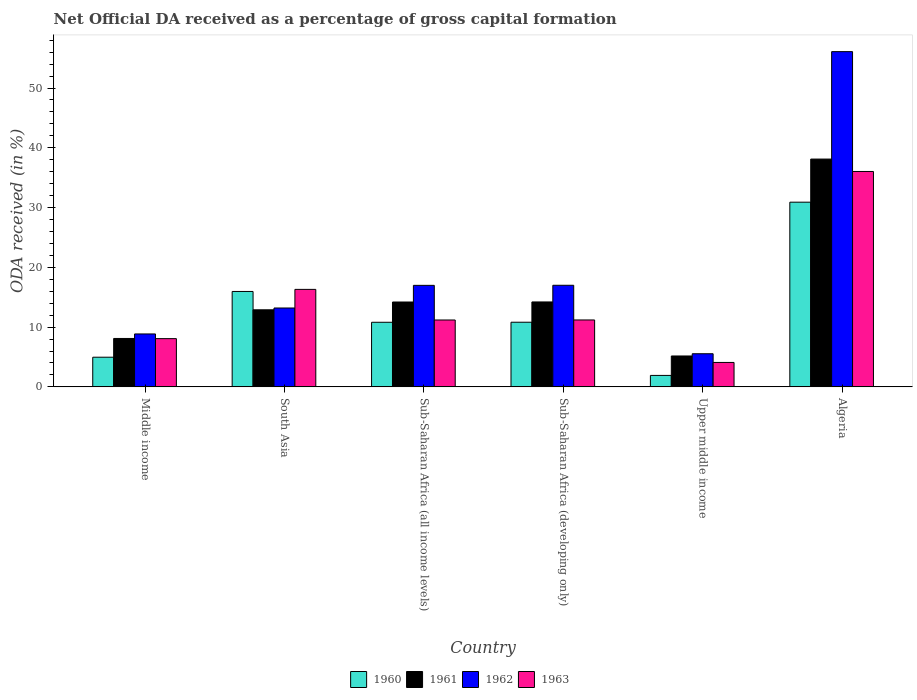Are the number of bars on each tick of the X-axis equal?
Keep it short and to the point. Yes. How many bars are there on the 1st tick from the right?
Give a very brief answer. 4. What is the label of the 2nd group of bars from the left?
Offer a very short reply. South Asia. What is the net ODA received in 1962 in Sub-Saharan Africa (all income levels)?
Offer a very short reply. 16.99. Across all countries, what is the maximum net ODA received in 1961?
Ensure brevity in your answer.  38.11. Across all countries, what is the minimum net ODA received in 1963?
Keep it short and to the point. 4.09. In which country was the net ODA received in 1961 maximum?
Your answer should be compact. Algeria. In which country was the net ODA received in 1961 minimum?
Provide a short and direct response. Upper middle income. What is the total net ODA received in 1960 in the graph?
Your response must be concise. 75.37. What is the difference between the net ODA received in 1963 in Sub-Saharan Africa (developing only) and that in Upper middle income?
Give a very brief answer. 7.11. What is the difference between the net ODA received in 1961 in Middle income and the net ODA received in 1963 in South Asia?
Keep it short and to the point. -8.21. What is the average net ODA received in 1960 per country?
Offer a terse response. 12.56. What is the difference between the net ODA received of/in 1963 and net ODA received of/in 1962 in Sub-Saharan Africa (all income levels)?
Keep it short and to the point. -5.8. What is the ratio of the net ODA received in 1963 in Algeria to that in South Asia?
Offer a terse response. 2.21. Is the net ODA received in 1961 in Algeria less than that in South Asia?
Offer a terse response. No. What is the difference between the highest and the second highest net ODA received in 1961?
Offer a very short reply. -23.91. What is the difference between the highest and the lowest net ODA received in 1962?
Your answer should be very brief. 50.54. In how many countries, is the net ODA received in 1963 greater than the average net ODA received in 1963 taken over all countries?
Offer a very short reply. 2. Is the sum of the net ODA received in 1960 in Sub-Saharan Africa (developing only) and Upper middle income greater than the maximum net ODA received in 1961 across all countries?
Your answer should be very brief. No. Is it the case that in every country, the sum of the net ODA received in 1961 and net ODA received in 1960 is greater than the sum of net ODA received in 1962 and net ODA received in 1963?
Make the answer very short. No. What does the 2nd bar from the right in Sub-Saharan Africa (developing only) represents?
Your answer should be compact. 1962. Are all the bars in the graph horizontal?
Keep it short and to the point. No. What is the difference between two consecutive major ticks on the Y-axis?
Offer a very short reply. 10. Does the graph contain grids?
Your answer should be very brief. No. Where does the legend appear in the graph?
Give a very brief answer. Bottom center. How many legend labels are there?
Offer a terse response. 4. What is the title of the graph?
Keep it short and to the point. Net Official DA received as a percentage of gross capital formation. Does "1965" appear as one of the legend labels in the graph?
Your answer should be compact. No. What is the label or title of the Y-axis?
Provide a short and direct response. ODA received (in %). What is the ODA received (in %) of 1960 in Middle income?
Your answer should be compact. 4.96. What is the ODA received (in %) in 1961 in Middle income?
Offer a terse response. 8.1. What is the ODA received (in %) in 1962 in Middle income?
Provide a short and direct response. 8.85. What is the ODA received (in %) of 1963 in Middle income?
Offer a very short reply. 8.07. What is the ODA received (in %) of 1960 in South Asia?
Offer a very short reply. 15.96. What is the ODA received (in %) in 1961 in South Asia?
Offer a very short reply. 12.89. What is the ODA received (in %) of 1962 in South Asia?
Ensure brevity in your answer.  13.2. What is the ODA received (in %) of 1963 in South Asia?
Your answer should be very brief. 16.31. What is the ODA received (in %) of 1960 in Sub-Saharan Africa (all income levels)?
Offer a very short reply. 10.81. What is the ODA received (in %) of 1961 in Sub-Saharan Africa (all income levels)?
Ensure brevity in your answer.  14.2. What is the ODA received (in %) of 1962 in Sub-Saharan Africa (all income levels)?
Offer a very short reply. 16.99. What is the ODA received (in %) of 1963 in Sub-Saharan Africa (all income levels)?
Keep it short and to the point. 11.19. What is the ODA received (in %) of 1960 in Sub-Saharan Africa (developing only)?
Your answer should be compact. 10.82. What is the ODA received (in %) of 1961 in Sub-Saharan Africa (developing only)?
Offer a very short reply. 14.21. What is the ODA received (in %) in 1962 in Sub-Saharan Africa (developing only)?
Your response must be concise. 17. What is the ODA received (in %) of 1963 in Sub-Saharan Africa (developing only)?
Offer a terse response. 11.2. What is the ODA received (in %) of 1960 in Upper middle income?
Ensure brevity in your answer.  1.92. What is the ODA received (in %) of 1961 in Upper middle income?
Keep it short and to the point. 5.17. What is the ODA received (in %) in 1962 in Upper middle income?
Your response must be concise. 5.54. What is the ODA received (in %) of 1963 in Upper middle income?
Offer a terse response. 4.09. What is the ODA received (in %) in 1960 in Algeria?
Provide a short and direct response. 30.9. What is the ODA received (in %) of 1961 in Algeria?
Keep it short and to the point. 38.11. What is the ODA received (in %) in 1962 in Algeria?
Your response must be concise. 56.09. What is the ODA received (in %) in 1963 in Algeria?
Ensure brevity in your answer.  36.04. Across all countries, what is the maximum ODA received (in %) of 1960?
Provide a succinct answer. 30.9. Across all countries, what is the maximum ODA received (in %) of 1961?
Keep it short and to the point. 38.11. Across all countries, what is the maximum ODA received (in %) in 1962?
Your answer should be very brief. 56.09. Across all countries, what is the maximum ODA received (in %) in 1963?
Provide a succinct answer. 36.04. Across all countries, what is the minimum ODA received (in %) of 1960?
Provide a succinct answer. 1.92. Across all countries, what is the minimum ODA received (in %) in 1961?
Ensure brevity in your answer.  5.17. Across all countries, what is the minimum ODA received (in %) of 1962?
Make the answer very short. 5.54. Across all countries, what is the minimum ODA received (in %) in 1963?
Provide a short and direct response. 4.09. What is the total ODA received (in %) of 1960 in the graph?
Offer a terse response. 75.37. What is the total ODA received (in %) in 1961 in the graph?
Make the answer very short. 92.69. What is the total ODA received (in %) of 1962 in the graph?
Your answer should be very brief. 117.67. What is the total ODA received (in %) in 1963 in the graph?
Your answer should be very brief. 86.89. What is the difference between the ODA received (in %) of 1960 in Middle income and that in South Asia?
Keep it short and to the point. -11. What is the difference between the ODA received (in %) in 1961 in Middle income and that in South Asia?
Your answer should be very brief. -4.79. What is the difference between the ODA received (in %) of 1962 in Middle income and that in South Asia?
Ensure brevity in your answer.  -4.34. What is the difference between the ODA received (in %) in 1963 in Middle income and that in South Asia?
Make the answer very short. -8.24. What is the difference between the ODA received (in %) in 1960 in Middle income and that in Sub-Saharan Africa (all income levels)?
Ensure brevity in your answer.  -5.85. What is the difference between the ODA received (in %) in 1961 in Middle income and that in Sub-Saharan Africa (all income levels)?
Provide a short and direct response. -6.1. What is the difference between the ODA received (in %) in 1962 in Middle income and that in Sub-Saharan Africa (all income levels)?
Provide a short and direct response. -8.13. What is the difference between the ODA received (in %) of 1963 in Middle income and that in Sub-Saharan Africa (all income levels)?
Keep it short and to the point. -3.12. What is the difference between the ODA received (in %) of 1960 in Middle income and that in Sub-Saharan Africa (developing only)?
Your answer should be very brief. -5.85. What is the difference between the ODA received (in %) of 1961 in Middle income and that in Sub-Saharan Africa (developing only)?
Your answer should be compact. -6.11. What is the difference between the ODA received (in %) of 1962 in Middle income and that in Sub-Saharan Africa (developing only)?
Make the answer very short. -8.14. What is the difference between the ODA received (in %) in 1963 in Middle income and that in Sub-Saharan Africa (developing only)?
Provide a succinct answer. -3.12. What is the difference between the ODA received (in %) of 1960 in Middle income and that in Upper middle income?
Make the answer very short. 3.05. What is the difference between the ODA received (in %) in 1961 in Middle income and that in Upper middle income?
Give a very brief answer. 2.93. What is the difference between the ODA received (in %) in 1962 in Middle income and that in Upper middle income?
Your answer should be compact. 3.31. What is the difference between the ODA received (in %) of 1963 in Middle income and that in Upper middle income?
Your response must be concise. 3.98. What is the difference between the ODA received (in %) of 1960 in Middle income and that in Algeria?
Offer a terse response. -25.94. What is the difference between the ODA received (in %) in 1961 in Middle income and that in Algeria?
Keep it short and to the point. -30.01. What is the difference between the ODA received (in %) of 1962 in Middle income and that in Algeria?
Make the answer very short. -47.23. What is the difference between the ODA received (in %) of 1963 in Middle income and that in Algeria?
Offer a terse response. -27.97. What is the difference between the ODA received (in %) of 1960 in South Asia and that in Sub-Saharan Africa (all income levels)?
Provide a short and direct response. 5.15. What is the difference between the ODA received (in %) in 1961 in South Asia and that in Sub-Saharan Africa (all income levels)?
Your response must be concise. -1.31. What is the difference between the ODA received (in %) in 1962 in South Asia and that in Sub-Saharan Africa (all income levels)?
Offer a very short reply. -3.79. What is the difference between the ODA received (in %) of 1963 in South Asia and that in Sub-Saharan Africa (all income levels)?
Make the answer very short. 5.12. What is the difference between the ODA received (in %) in 1960 in South Asia and that in Sub-Saharan Africa (developing only)?
Your answer should be compact. 5.15. What is the difference between the ODA received (in %) of 1961 in South Asia and that in Sub-Saharan Africa (developing only)?
Keep it short and to the point. -1.32. What is the difference between the ODA received (in %) in 1962 in South Asia and that in Sub-Saharan Africa (developing only)?
Offer a terse response. -3.8. What is the difference between the ODA received (in %) of 1963 in South Asia and that in Sub-Saharan Africa (developing only)?
Give a very brief answer. 5.12. What is the difference between the ODA received (in %) of 1960 in South Asia and that in Upper middle income?
Keep it short and to the point. 14.05. What is the difference between the ODA received (in %) of 1961 in South Asia and that in Upper middle income?
Keep it short and to the point. 7.72. What is the difference between the ODA received (in %) in 1962 in South Asia and that in Upper middle income?
Offer a terse response. 7.65. What is the difference between the ODA received (in %) of 1963 in South Asia and that in Upper middle income?
Your response must be concise. 12.22. What is the difference between the ODA received (in %) in 1960 in South Asia and that in Algeria?
Offer a very short reply. -14.94. What is the difference between the ODA received (in %) in 1961 in South Asia and that in Algeria?
Ensure brevity in your answer.  -25.22. What is the difference between the ODA received (in %) of 1962 in South Asia and that in Algeria?
Your answer should be very brief. -42.89. What is the difference between the ODA received (in %) of 1963 in South Asia and that in Algeria?
Give a very brief answer. -19.73. What is the difference between the ODA received (in %) in 1960 in Sub-Saharan Africa (all income levels) and that in Sub-Saharan Africa (developing only)?
Your answer should be compact. -0.01. What is the difference between the ODA received (in %) in 1961 in Sub-Saharan Africa (all income levels) and that in Sub-Saharan Africa (developing only)?
Offer a terse response. -0.01. What is the difference between the ODA received (in %) of 1962 in Sub-Saharan Africa (all income levels) and that in Sub-Saharan Africa (developing only)?
Offer a terse response. -0.01. What is the difference between the ODA received (in %) in 1963 in Sub-Saharan Africa (all income levels) and that in Sub-Saharan Africa (developing only)?
Ensure brevity in your answer.  -0.01. What is the difference between the ODA received (in %) in 1960 in Sub-Saharan Africa (all income levels) and that in Upper middle income?
Your response must be concise. 8.89. What is the difference between the ODA received (in %) of 1961 in Sub-Saharan Africa (all income levels) and that in Upper middle income?
Your response must be concise. 9.03. What is the difference between the ODA received (in %) in 1962 in Sub-Saharan Africa (all income levels) and that in Upper middle income?
Offer a very short reply. 11.44. What is the difference between the ODA received (in %) of 1963 in Sub-Saharan Africa (all income levels) and that in Upper middle income?
Ensure brevity in your answer.  7.1. What is the difference between the ODA received (in %) of 1960 in Sub-Saharan Africa (all income levels) and that in Algeria?
Your answer should be very brief. -20.09. What is the difference between the ODA received (in %) of 1961 in Sub-Saharan Africa (all income levels) and that in Algeria?
Provide a short and direct response. -23.91. What is the difference between the ODA received (in %) of 1962 in Sub-Saharan Africa (all income levels) and that in Algeria?
Your response must be concise. -39.1. What is the difference between the ODA received (in %) in 1963 in Sub-Saharan Africa (all income levels) and that in Algeria?
Make the answer very short. -24.85. What is the difference between the ODA received (in %) of 1960 in Sub-Saharan Africa (developing only) and that in Upper middle income?
Offer a very short reply. 8.9. What is the difference between the ODA received (in %) in 1961 in Sub-Saharan Africa (developing only) and that in Upper middle income?
Ensure brevity in your answer.  9.04. What is the difference between the ODA received (in %) in 1962 in Sub-Saharan Africa (developing only) and that in Upper middle income?
Ensure brevity in your answer.  11.45. What is the difference between the ODA received (in %) in 1963 in Sub-Saharan Africa (developing only) and that in Upper middle income?
Provide a short and direct response. 7.11. What is the difference between the ODA received (in %) in 1960 in Sub-Saharan Africa (developing only) and that in Algeria?
Your answer should be very brief. -20.09. What is the difference between the ODA received (in %) of 1961 in Sub-Saharan Africa (developing only) and that in Algeria?
Your answer should be compact. -23.9. What is the difference between the ODA received (in %) in 1962 in Sub-Saharan Africa (developing only) and that in Algeria?
Keep it short and to the point. -39.09. What is the difference between the ODA received (in %) of 1963 in Sub-Saharan Africa (developing only) and that in Algeria?
Give a very brief answer. -24.84. What is the difference between the ODA received (in %) of 1960 in Upper middle income and that in Algeria?
Offer a very short reply. -28.99. What is the difference between the ODA received (in %) of 1961 in Upper middle income and that in Algeria?
Keep it short and to the point. -32.94. What is the difference between the ODA received (in %) in 1962 in Upper middle income and that in Algeria?
Keep it short and to the point. -50.54. What is the difference between the ODA received (in %) in 1963 in Upper middle income and that in Algeria?
Give a very brief answer. -31.95. What is the difference between the ODA received (in %) of 1960 in Middle income and the ODA received (in %) of 1961 in South Asia?
Give a very brief answer. -7.93. What is the difference between the ODA received (in %) in 1960 in Middle income and the ODA received (in %) in 1962 in South Asia?
Keep it short and to the point. -8.23. What is the difference between the ODA received (in %) in 1960 in Middle income and the ODA received (in %) in 1963 in South Asia?
Offer a very short reply. -11.35. What is the difference between the ODA received (in %) in 1961 in Middle income and the ODA received (in %) in 1962 in South Asia?
Keep it short and to the point. -5.1. What is the difference between the ODA received (in %) of 1961 in Middle income and the ODA received (in %) of 1963 in South Asia?
Make the answer very short. -8.21. What is the difference between the ODA received (in %) of 1962 in Middle income and the ODA received (in %) of 1963 in South Asia?
Offer a terse response. -7.46. What is the difference between the ODA received (in %) of 1960 in Middle income and the ODA received (in %) of 1961 in Sub-Saharan Africa (all income levels)?
Offer a very short reply. -9.24. What is the difference between the ODA received (in %) of 1960 in Middle income and the ODA received (in %) of 1962 in Sub-Saharan Africa (all income levels)?
Provide a succinct answer. -12.02. What is the difference between the ODA received (in %) in 1960 in Middle income and the ODA received (in %) in 1963 in Sub-Saharan Africa (all income levels)?
Your response must be concise. -6.23. What is the difference between the ODA received (in %) in 1961 in Middle income and the ODA received (in %) in 1962 in Sub-Saharan Africa (all income levels)?
Provide a short and direct response. -8.89. What is the difference between the ODA received (in %) of 1961 in Middle income and the ODA received (in %) of 1963 in Sub-Saharan Africa (all income levels)?
Keep it short and to the point. -3.09. What is the difference between the ODA received (in %) of 1962 in Middle income and the ODA received (in %) of 1963 in Sub-Saharan Africa (all income levels)?
Keep it short and to the point. -2.33. What is the difference between the ODA received (in %) in 1960 in Middle income and the ODA received (in %) in 1961 in Sub-Saharan Africa (developing only)?
Offer a terse response. -9.25. What is the difference between the ODA received (in %) in 1960 in Middle income and the ODA received (in %) in 1962 in Sub-Saharan Africa (developing only)?
Make the answer very short. -12.04. What is the difference between the ODA received (in %) in 1960 in Middle income and the ODA received (in %) in 1963 in Sub-Saharan Africa (developing only)?
Offer a very short reply. -6.23. What is the difference between the ODA received (in %) in 1961 in Middle income and the ODA received (in %) in 1962 in Sub-Saharan Africa (developing only)?
Keep it short and to the point. -8.9. What is the difference between the ODA received (in %) in 1961 in Middle income and the ODA received (in %) in 1963 in Sub-Saharan Africa (developing only)?
Keep it short and to the point. -3.1. What is the difference between the ODA received (in %) in 1962 in Middle income and the ODA received (in %) in 1963 in Sub-Saharan Africa (developing only)?
Make the answer very short. -2.34. What is the difference between the ODA received (in %) of 1960 in Middle income and the ODA received (in %) of 1961 in Upper middle income?
Keep it short and to the point. -0.21. What is the difference between the ODA received (in %) in 1960 in Middle income and the ODA received (in %) in 1962 in Upper middle income?
Provide a short and direct response. -0.58. What is the difference between the ODA received (in %) in 1960 in Middle income and the ODA received (in %) in 1963 in Upper middle income?
Ensure brevity in your answer.  0.87. What is the difference between the ODA received (in %) in 1961 in Middle income and the ODA received (in %) in 1962 in Upper middle income?
Ensure brevity in your answer.  2.56. What is the difference between the ODA received (in %) of 1961 in Middle income and the ODA received (in %) of 1963 in Upper middle income?
Your answer should be compact. 4.01. What is the difference between the ODA received (in %) of 1962 in Middle income and the ODA received (in %) of 1963 in Upper middle income?
Give a very brief answer. 4.77. What is the difference between the ODA received (in %) in 1960 in Middle income and the ODA received (in %) in 1961 in Algeria?
Offer a very short reply. -33.15. What is the difference between the ODA received (in %) of 1960 in Middle income and the ODA received (in %) of 1962 in Algeria?
Make the answer very short. -51.13. What is the difference between the ODA received (in %) of 1960 in Middle income and the ODA received (in %) of 1963 in Algeria?
Provide a succinct answer. -31.08. What is the difference between the ODA received (in %) in 1961 in Middle income and the ODA received (in %) in 1962 in Algeria?
Give a very brief answer. -47.99. What is the difference between the ODA received (in %) in 1961 in Middle income and the ODA received (in %) in 1963 in Algeria?
Your answer should be very brief. -27.94. What is the difference between the ODA received (in %) of 1962 in Middle income and the ODA received (in %) of 1963 in Algeria?
Make the answer very short. -27.18. What is the difference between the ODA received (in %) of 1960 in South Asia and the ODA received (in %) of 1961 in Sub-Saharan Africa (all income levels)?
Ensure brevity in your answer.  1.76. What is the difference between the ODA received (in %) of 1960 in South Asia and the ODA received (in %) of 1962 in Sub-Saharan Africa (all income levels)?
Keep it short and to the point. -1.02. What is the difference between the ODA received (in %) in 1960 in South Asia and the ODA received (in %) in 1963 in Sub-Saharan Africa (all income levels)?
Your response must be concise. 4.77. What is the difference between the ODA received (in %) of 1961 in South Asia and the ODA received (in %) of 1962 in Sub-Saharan Africa (all income levels)?
Provide a succinct answer. -4.09. What is the difference between the ODA received (in %) in 1961 in South Asia and the ODA received (in %) in 1963 in Sub-Saharan Africa (all income levels)?
Make the answer very short. 1.7. What is the difference between the ODA received (in %) in 1962 in South Asia and the ODA received (in %) in 1963 in Sub-Saharan Africa (all income levels)?
Offer a terse response. 2.01. What is the difference between the ODA received (in %) of 1960 in South Asia and the ODA received (in %) of 1961 in Sub-Saharan Africa (developing only)?
Ensure brevity in your answer.  1.75. What is the difference between the ODA received (in %) in 1960 in South Asia and the ODA received (in %) in 1962 in Sub-Saharan Africa (developing only)?
Your answer should be compact. -1.03. What is the difference between the ODA received (in %) in 1960 in South Asia and the ODA received (in %) in 1963 in Sub-Saharan Africa (developing only)?
Offer a terse response. 4.77. What is the difference between the ODA received (in %) of 1961 in South Asia and the ODA received (in %) of 1962 in Sub-Saharan Africa (developing only)?
Your answer should be compact. -4.11. What is the difference between the ODA received (in %) in 1961 in South Asia and the ODA received (in %) in 1963 in Sub-Saharan Africa (developing only)?
Your answer should be compact. 1.7. What is the difference between the ODA received (in %) of 1962 in South Asia and the ODA received (in %) of 1963 in Sub-Saharan Africa (developing only)?
Keep it short and to the point. 2. What is the difference between the ODA received (in %) of 1960 in South Asia and the ODA received (in %) of 1961 in Upper middle income?
Keep it short and to the point. 10.79. What is the difference between the ODA received (in %) in 1960 in South Asia and the ODA received (in %) in 1962 in Upper middle income?
Keep it short and to the point. 10.42. What is the difference between the ODA received (in %) in 1960 in South Asia and the ODA received (in %) in 1963 in Upper middle income?
Provide a succinct answer. 11.88. What is the difference between the ODA received (in %) of 1961 in South Asia and the ODA received (in %) of 1962 in Upper middle income?
Give a very brief answer. 7.35. What is the difference between the ODA received (in %) of 1961 in South Asia and the ODA received (in %) of 1963 in Upper middle income?
Provide a succinct answer. 8.81. What is the difference between the ODA received (in %) in 1962 in South Asia and the ODA received (in %) in 1963 in Upper middle income?
Offer a terse response. 9.11. What is the difference between the ODA received (in %) of 1960 in South Asia and the ODA received (in %) of 1961 in Algeria?
Offer a very short reply. -22.15. What is the difference between the ODA received (in %) in 1960 in South Asia and the ODA received (in %) in 1962 in Algeria?
Provide a succinct answer. -40.13. What is the difference between the ODA received (in %) of 1960 in South Asia and the ODA received (in %) of 1963 in Algeria?
Offer a terse response. -20.07. What is the difference between the ODA received (in %) in 1961 in South Asia and the ODA received (in %) in 1962 in Algeria?
Your answer should be very brief. -43.2. What is the difference between the ODA received (in %) of 1961 in South Asia and the ODA received (in %) of 1963 in Algeria?
Your answer should be compact. -23.14. What is the difference between the ODA received (in %) in 1962 in South Asia and the ODA received (in %) in 1963 in Algeria?
Ensure brevity in your answer.  -22.84. What is the difference between the ODA received (in %) of 1960 in Sub-Saharan Africa (all income levels) and the ODA received (in %) of 1961 in Sub-Saharan Africa (developing only)?
Provide a succinct answer. -3.4. What is the difference between the ODA received (in %) of 1960 in Sub-Saharan Africa (all income levels) and the ODA received (in %) of 1962 in Sub-Saharan Africa (developing only)?
Keep it short and to the point. -6.19. What is the difference between the ODA received (in %) in 1960 in Sub-Saharan Africa (all income levels) and the ODA received (in %) in 1963 in Sub-Saharan Africa (developing only)?
Provide a short and direct response. -0.39. What is the difference between the ODA received (in %) of 1961 in Sub-Saharan Africa (all income levels) and the ODA received (in %) of 1962 in Sub-Saharan Africa (developing only)?
Ensure brevity in your answer.  -2.8. What is the difference between the ODA received (in %) of 1961 in Sub-Saharan Africa (all income levels) and the ODA received (in %) of 1963 in Sub-Saharan Africa (developing only)?
Make the answer very short. 3. What is the difference between the ODA received (in %) in 1962 in Sub-Saharan Africa (all income levels) and the ODA received (in %) in 1963 in Sub-Saharan Africa (developing only)?
Your answer should be very brief. 5.79. What is the difference between the ODA received (in %) of 1960 in Sub-Saharan Africa (all income levels) and the ODA received (in %) of 1961 in Upper middle income?
Make the answer very short. 5.64. What is the difference between the ODA received (in %) of 1960 in Sub-Saharan Africa (all income levels) and the ODA received (in %) of 1962 in Upper middle income?
Ensure brevity in your answer.  5.27. What is the difference between the ODA received (in %) of 1960 in Sub-Saharan Africa (all income levels) and the ODA received (in %) of 1963 in Upper middle income?
Your answer should be very brief. 6.72. What is the difference between the ODA received (in %) in 1961 in Sub-Saharan Africa (all income levels) and the ODA received (in %) in 1962 in Upper middle income?
Offer a terse response. 8.66. What is the difference between the ODA received (in %) of 1961 in Sub-Saharan Africa (all income levels) and the ODA received (in %) of 1963 in Upper middle income?
Offer a terse response. 10.11. What is the difference between the ODA received (in %) of 1962 in Sub-Saharan Africa (all income levels) and the ODA received (in %) of 1963 in Upper middle income?
Ensure brevity in your answer.  12.9. What is the difference between the ODA received (in %) of 1960 in Sub-Saharan Africa (all income levels) and the ODA received (in %) of 1961 in Algeria?
Provide a succinct answer. -27.3. What is the difference between the ODA received (in %) in 1960 in Sub-Saharan Africa (all income levels) and the ODA received (in %) in 1962 in Algeria?
Offer a very short reply. -45.28. What is the difference between the ODA received (in %) in 1960 in Sub-Saharan Africa (all income levels) and the ODA received (in %) in 1963 in Algeria?
Provide a succinct answer. -25.23. What is the difference between the ODA received (in %) of 1961 in Sub-Saharan Africa (all income levels) and the ODA received (in %) of 1962 in Algeria?
Provide a short and direct response. -41.89. What is the difference between the ODA received (in %) in 1961 in Sub-Saharan Africa (all income levels) and the ODA received (in %) in 1963 in Algeria?
Provide a succinct answer. -21.84. What is the difference between the ODA received (in %) in 1962 in Sub-Saharan Africa (all income levels) and the ODA received (in %) in 1963 in Algeria?
Provide a short and direct response. -19.05. What is the difference between the ODA received (in %) of 1960 in Sub-Saharan Africa (developing only) and the ODA received (in %) of 1961 in Upper middle income?
Offer a terse response. 5.65. What is the difference between the ODA received (in %) in 1960 in Sub-Saharan Africa (developing only) and the ODA received (in %) in 1962 in Upper middle income?
Keep it short and to the point. 5.27. What is the difference between the ODA received (in %) of 1960 in Sub-Saharan Africa (developing only) and the ODA received (in %) of 1963 in Upper middle income?
Provide a succinct answer. 6.73. What is the difference between the ODA received (in %) in 1961 in Sub-Saharan Africa (developing only) and the ODA received (in %) in 1962 in Upper middle income?
Your answer should be compact. 8.67. What is the difference between the ODA received (in %) of 1961 in Sub-Saharan Africa (developing only) and the ODA received (in %) of 1963 in Upper middle income?
Provide a short and direct response. 10.12. What is the difference between the ODA received (in %) in 1962 in Sub-Saharan Africa (developing only) and the ODA received (in %) in 1963 in Upper middle income?
Keep it short and to the point. 12.91. What is the difference between the ODA received (in %) in 1960 in Sub-Saharan Africa (developing only) and the ODA received (in %) in 1961 in Algeria?
Your response must be concise. -27.3. What is the difference between the ODA received (in %) of 1960 in Sub-Saharan Africa (developing only) and the ODA received (in %) of 1962 in Algeria?
Your response must be concise. -45.27. What is the difference between the ODA received (in %) of 1960 in Sub-Saharan Africa (developing only) and the ODA received (in %) of 1963 in Algeria?
Your answer should be compact. -25.22. What is the difference between the ODA received (in %) of 1961 in Sub-Saharan Africa (developing only) and the ODA received (in %) of 1962 in Algeria?
Provide a short and direct response. -41.88. What is the difference between the ODA received (in %) in 1961 in Sub-Saharan Africa (developing only) and the ODA received (in %) in 1963 in Algeria?
Offer a very short reply. -21.83. What is the difference between the ODA received (in %) in 1962 in Sub-Saharan Africa (developing only) and the ODA received (in %) in 1963 in Algeria?
Provide a short and direct response. -19.04. What is the difference between the ODA received (in %) in 1960 in Upper middle income and the ODA received (in %) in 1961 in Algeria?
Make the answer very short. -36.2. What is the difference between the ODA received (in %) in 1960 in Upper middle income and the ODA received (in %) in 1962 in Algeria?
Give a very brief answer. -54.17. What is the difference between the ODA received (in %) of 1960 in Upper middle income and the ODA received (in %) of 1963 in Algeria?
Provide a succinct answer. -34.12. What is the difference between the ODA received (in %) in 1961 in Upper middle income and the ODA received (in %) in 1962 in Algeria?
Your response must be concise. -50.92. What is the difference between the ODA received (in %) of 1961 in Upper middle income and the ODA received (in %) of 1963 in Algeria?
Your response must be concise. -30.87. What is the difference between the ODA received (in %) of 1962 in Upper middle income and the ODA received (in %) of 1963 in Algeria?
Your response must be concise. -30.49. What is the average ODA received (in %) in 1960 per country?
Give a very brief answer. 12.56. What is the average ODA received (in %) of 1961 per country?
Ensure brevity in your answer.  15.45. What is the average ODA received (in %) in 1962 per country?
Provide a short and direct response. 19.61. What is the average ODA received (in %) in 1963 per country?
Give a very brief answer. 14.48. What is the difference between the ODA received (in %) of 1960 and ODA received (in %) of 1961 in Middle income?
Your answer should be compact. -3.14. What is the difference between the ODA received (in %) in 1960 and ODA received (in %) in 1962 in Middle income?
Keep it short and to the point. -3.89. What is the difference between the ODA received (in %) of 1960 and ODA received (in %) of 1963 in Middle income?
Provide a succinct answer. -3.11. What is the difference between the ODA received (in %) in 1961 and ODA received (in %) in 1962 in Middle income?
Your answer should be very brief. -0.75. What is the difference between the ODA received (in %) of 1961 and ODA received (in %) of 1963 in Middle income?
Your answer should be very brief. 0.03. What is the difference between the ODA received (in %) in 1962 and ODA received (in %) in 1963 in Middle income?
Your answer should be very brief. 0.78. What is the difference between the ODA received (in %) of 1960 and ODA received (in %) of 1961 in South Asia?
Offer a terse response. 3.07. What is the difference between the ODA received (in %) of 1960 and ODA received (in %) of 1962 in South Asia?
Provide a succinct answer. 2.77. What is the difference between the ODA received (in %) of 1960 and ODA received (in %) of 1963 in South Asia?
Your response must be concise. -0.35. What is the difference between the ODA received (in %) in 1961 and ODA received (in %) in 1962 in South Asia?
Offer a terse response. -0.3. What is the difference between the ODA received (in %) of 1961 and ODA received (in %) of 1963 in South Asia?
Your answer should be compact. -3.42. What is the difference between the ODA received (in %) of 1962 and ODA received (in %) of 1963 in South Asia?
Offer a terse response. -3.11. What is the difference between the ODA received (in %) in 1960 and ODA received (in %) in 1961 in Sub-Saharan Africa (all income levels)?
Keep it short and to the point. -3.39. What is the difference between the ODA received (in %) of 1960 and ODA received (in %) of 1962 in Sub-Saharan Africa (all income levels)?
Offer a terse response. -6.18. What is the difference between the ODA received (in %) of 1960 and ODA received (in %) of 1963 in Sub-Saharan Africa (all income levels)?
Provide a short and direct response. -0.38. What is the difference between the ODA received (in %) in 1961 and ODA received (in %) in 1962 in Sub-Saharan Africa (all income levels)?
Offer a terse response. -2.79. What is the difference between the ODA received (in %) in 1961 and ODA received (in %) in 1963 in Sub-Saharan Africa (all income levels)?
Your answer should be very brief. 3.01. What is the difference between the ODA received (in %) of 1962 and ODA received (in %) of 1963 in Sub-Saharan Africa (all income levels)?
Make the answer very short. 5.8. What is the difference between the ODA received (in %) of 1960 and ODA received (in %) of 1961 in Sub-Saharan Africa (developing only)?
Offer a terse response. -3.39. What is the difference between the ODA received (in %) in 1960 and ODA received (in %) in 1962 in Sub-Saharan Africa (developing only)?
Offer a terse response. -6.18. What is the difference between the ODA received (in %) in 1960 and ODA received (in %) in 1963 in Sub-Saharan Africa (developing only)?
Give a very brief answer. -0.38. What is the difference between the ODA received (in %) of 1961 and ODA received (in %) of 1962 in Sub-Saharan Africa (developing only)?
Offer a terse response. -2.79. What is the difference between the ODA received (in %) of 1961 and ODA received (in %) of 1963 in Sub-Saharan Africa (developing only)?
Ensure brevity in your answer.  3.01. What is the difference between the ODA received (in %) in 1962 and ODA received (in %) in 1963 in Sub-Saharan Africa (developing only)?
Offer a very short reply. 5.8. What is the difference between the ODA received (in %) in 1960 and ODA received (in %) in 1961 in Upper middle income?
Your answer should be very brief. -3.25. What is the difference between the ODA received (in %) in 1960 and ODA received (in %) in 1962 in Upper middle income?
Give a very brief answer. -3.63. What is the difference between the ODA received (in %) in 1960 and ODA received (in %) in 1963 in Upper middle income?
Make the answer very short. -2.17. What is the difference between the ODA received (in %) in 1961 and ODA received (in %) in 1962 in Upper middle income?
Your answer should be very brief. -0.37. What is the difference between the ODA received (in %) of 1961 and ODA received (in %) of 1963 in Upper middle income?
Your answer should be very brief. 1.08. What is the difference between the ODA received (in %) in 1962 and ODA received (in %) in 1963 in Upper middle income?
Ensure brevity in your answer.  1.46. What is the difference between the ODA received (in %) of 1960 and ODA received (in %) of 1961 in Algeria?
Offer a very short reply. -7.21. What is the difference between the ODA received (in %) in 1960 and ODA received (in %) in 1962 in Algeria?
Offer a very short reply. -25.19. What is the difference between the ODA received (in %) of 1960 and ODA received (in %) of 1963 in Algeria?
Offer a terse response. -5.14. What is the difference between the ODA received (in %) of 1961 and ODA received (in %) of 1962 in Algeria?
Provide a succinct answer. -17.98. What is the difference between the ODA received (in %) in 1961 and ODA received (in %) in 1963 in Algeria?
Offer a terse response. 2.08. What is the difference between the ODA received (in %) in 1962 and ODA received (in %) in 1963 in Algeria?
Make the answer very short. 20.05. What is the ratio of the ODA received (in %) in 1960 in Middle income to that in South Asia?
Offer a very short reply. 0.31. What is the ratio of the ODA received (in %) in 1961 in Middle income to that in South Asia?
Your answer should be very brief. 0.63. What is the ratio of the ODA received (in %) in 1962 in Middle income to that in South Asia?
Provide a succinct answer. 0.67. What is the ratio of the ODA received (in %) in 1963 in Middle income to that in South Asia?
Your answer should be compact. 0.49. What is the ratio of the ODA received (in %) of 1960 in Middle income to that in Sub-Saharan Africa (all income levels)?
Your answer should be very brief. 0.46. What is the ratio of the ODA received (in %) of 1961 in Middle income to that in Sub-Saharan Africa (all income levels)?
Your response must be concise. 0.57. What is the ratio of the ODA received (in %) in 1962 in Middle income to that in Sub-Saharan Africa (all income levels)?
Give a very brief answer. 0.52. What is the ratio of the ODA received (in %) in 1963 in Middle income to that in Sub-Saharan Africa (all income levels)?
Make the answer very short. 0.72. What is the ratio of the ODA received (in %) of 1960 in Middle income to that in Sub-Saharan Africa (developing only)?
Offer a terse response. 0.46. What is the ratio of the ODA received (in %) of 1961 in Middle income to that in Sub-Saharan Africa (developing only)?
Keep it short and to the point. 0.57. What is the ratio of the ODA received (in %) in 1962 in Middle income to that in Sub-Saharan Africa (developing only)?
Make the answer very short. 0.52. What is the ratio of the ODA received (in %) of 1963 in Middle income to that in Sub-Saharan Africa (developing only)?
Provide a succinct answer. 0.72. What is the ratio of the ODA received (in %) in 1960 in Middle income to that in Upper middle income?
Ensure brevity in your answer.  2.59. What is the ratio of the ODA received (in %) of 1961 in Middle income to that in Upper middle income?
Give a very brief answer. 1.57. What is the ratio of the ODA received (in %) in 1962 in Middle income to that in Upper middle income?
Provide a succinct answer. 1.6. What is the ratio of the ODA received (in %) of 1963 in Middle income to that in Upper middle income?
Keep it short and to the point. 1.97. What is the ratio of the ODA received (in %) of 1960 in Middle income to that in Algeria?
Provide a succinct answer. 0.16. What is the ratio of the ODA received (in %) of 1961 in Middle income to that in Algeria?
Your answer should be very brief. 0.21. What is the ratio of the ODA received (in %) of 1962 in Middle income to that in Algeria?
Keep it short and to the point. 0.16. What is the ratio of the ODA received (in %) in 1963 in Middle income to that in Algeria?
Your response must be concise. 0.22. What is the ratio of the ODA received (in %) in 1960 in South Asia to that in Sub-Saharan Africa (all income levels)?
Provide a short and direct response. 1.48. What is the ratio of the ODA received (in %) of 1961 in South Asia to that in Sub-Saharan Africa (all income levels)?
Ensure brevity in your answer.  0.91. What is the ratio of the ODA received (in %) of 1962 in South Asia to that in Sub-Saharan Africa (all income levels)?
Ensure brevity in your answer.  0.78. What is the ratio of the ODA received (in %) of 1963 in South Asia to that in Sub-Saharan Africa (all income levels)?
Offer a terse response. 1.46. What is the ratio of the ODA received (in %) of 1960 in South Asia to that in Sub-Saharan Africa (developing only)?
Your answer should be compact. 1.48. What is the ratio of the ODA received (in %) of 1961 in South Asia to that in Sub-Saharan Africa (developing only)?
Provide a short and direct response. 0.91. What is the ratio of the ODA received (in %) of 1962 in South Asia to that in Sub-Saharan Africa (developing only)?
Provide a succinct answer. 0.78. What is the ratio of the ODA received (in %) in 1963 in South Asia to that in Sub-Saharan Africa (developing only)?
Provide a short and direct response. 1.46. What is the ratio of the ODA received (in %) of 1960 in South Asia to that in Upper middle income?
Provide a succinct answer. 8.33. What is the ratio of the ODA received (in %) of 1961 in South Asia to that in Upper middle income?
Your answer should be compact. 2.49. What is the ratio of the ODA received (in %) in 1962 in South Asia to that in Upper middle income?
Your answer should be very brief. 2.38. What is the ratio of the ODA received (in %) in 1963 in South Asia to that in Upper middle income?
Ensure brevity in your answer.  3.99. What is the ratio of the ODA received (in %) of 1960 in South Asia to that in Algeria?
Provide a succinct answer. 0.52. What is the ratio of the ODA received (in %) of 1961 in South Asia to that in Algeria?
Offer a terse response. 0.34. What is the ratio of the ODA received (in %) of 1962 in South Asia to that in Algeria?
Your answer should be compact. 0.24. What is the ratio of the ODA received (in %) of 1963 in South Asia to that in Algeria?
Keep it short and to the point. 0.45. What is the ratio of the ODA received (in %) of 1961 in Sub-Saharan Africa (all income levels) to that in Sub-Saharan Africa (developing only)?
Your answer should be very brief. 1. What is the ratio of the ODA received (in %) in 1960 in Sub-Saharan Africa (all income levels) to that in Upper middle income?
Ensure brevity in your answer.  5.64. What is the ratio of the ODA received (in %) in 1961 in Sub-Saharan Africa (all income levels) to that in Upper middle income?
Offer a very short reply. 2.75. What is the ratio of the ODA received (in %) in 1962 in Sub-Saharan Africa (all income levels) to that in Upper middle income?
Provide a short and direct response. 3.06. What is the ratio of the ODA received (in %) in 1963 in Sub-Saharan Africa (all income levels) to that in Upper middle income?
Provide a succinct answer. 2.74. What is the ratio of the ODA received (in %) in 1960 in Sub-Saharan Africa (all income levels) to that in Algeria?
Keep it short and to the point. 0.35. What is the ratio of the ODA received (in %) in 1961 in Sub-Saharan Africa (all income levels) to that in Algeria?
Provide a short and direct response. 0.37. What is the ratio of the ODA received (in %) in 1962 in Sub-Saharan Africa (all income levels) to that in Algeria?
Make the answer very short. 0.3. What is the ratio of the ODA received (in %) in 1963 in Sub-Saharan Africa (all income levels) to that in Algeria?
Provide a succinct answer. 0.31. What is the ratio of the ODA received (in %) in 1960 in Sub-Saharan Africa (developing only) to that in Upper middle income?
Keep it short and to the point. 5.65. What is the ratio of the ODA received (in %) of 1961 in Sub-Saharan Africa (developing only) to that in Upper middle income?
Your answer should be very brief. 2.75. What is the ratio of the ODA received (in %) of 1962 in Sub-Saharan Africa (developing only) to that in Upper middle income?
Your answer should be compact. 3.07. What is the ratio of the ODA received (in %) in 1963 in Sub-Saharan Africa (developing only) to that in Upper middle income?
Keep it short and to the point. 2.74. What is the ratio of the ODA received (in %) of 1960 in Sub-Saharan Africa (developing only) to that in Algeria?
Ensure brevity in your answer.  0.35. What is the ratio of the ODA received (in %) in 1961 in Sub-Saharan Africa (developing only) to that in Algeria?
Ensure brevity in your answer.  0.37. What is the ratio of the ODA received (in %) of 1962 in Sub-Saharan Africa (developing only) to that in Algeria?
Make the answer very short. 0.3. What is the ratio of the ODA received (in %) of 1963 in Sub-Saharan Africa (developing only) to that in Algeria?
Offer a terse response. 0.31. What is the ratio of the ODA received (in %) of 1960 in Upper middle income to that in Algeria?
Provide a succinct answer. 0.06. What is the ratio of the ODA received (in %) of 1961 in Upper middle income to that in Algeria?
Provide a short and direct response. 0.14. What is the ratio of the ODA received (in %) of 1962 in Upper middle income to that in Algeria?
Your answer should be compact. 0.1. What is the ratio of the ODA received (in %) of 1963 in Upper middle income to that in Algeria?
Ensure brevity in your answer.  0.11. What is the difference between the highest and the second highest ODA received (in %) of 1960?
Provide a short and direct response. 14.94. What is the difference between the highest and the second highest ODA received (in %) in 1961?
Offer a very short reply. 23.9. What is the difference between the highest and the second highest ODA received (in %) of 1962?
Make the answer very short. 39.09. What is the difference between the highest and the second highest ODA received (in %) of 1963?
Ensure brevity in your answer.  19.73. What is the difference between the highest and the lowest ODA received (in %) in 1960?
Your answer should be compact. 28.99. What is the difference between the highest and the lowest ODA received (in %) in 1961?
Your answer should be compact. 32.94. What is the difference between the highest and the lowest ODA received (in %) of 1962?
Make the answer very short. 50.54. What is the difference between the highest and the lowest ODA received (in %) in 1963?
Ensure brevity in your answer.  31.95. 